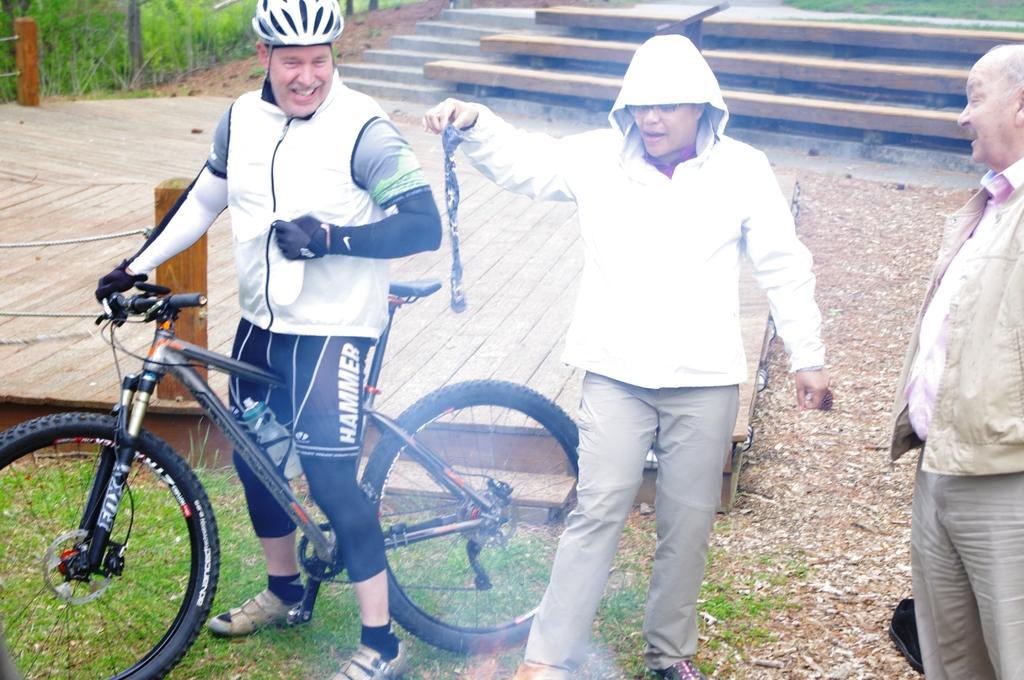Describe this image in one or two sentences. In this picture you can see a man with the bicycle. He is wearing a helmet on his head. He is catching the handle with his right hand. Beside him there is another man wearing jacket is holding something in his right hand. To the right corner there is another man standing and smiling. To the right top corner you can see some steps. And to the left top corner you can see grass. 